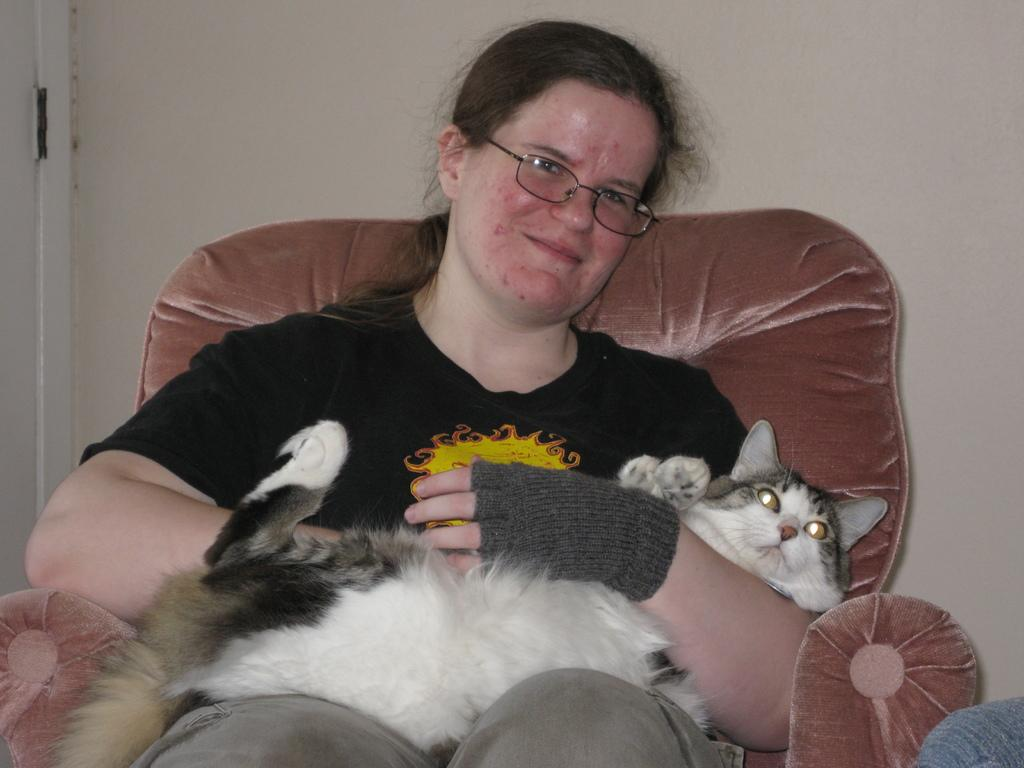Who is present in the image? There is a woman in the image. What is the woman doing in the image? The woman is sitting on a chair in the image. Is there any other living creature in the image besides the woman? Yes, there is a cat on the chair with the woman. What can be seen in the background of the image? There is a wall in the background of the image. What type of leaf is being used as a hat by the woman in the image? There is no leaf present in the image, and the woman is not wearing a hat. 